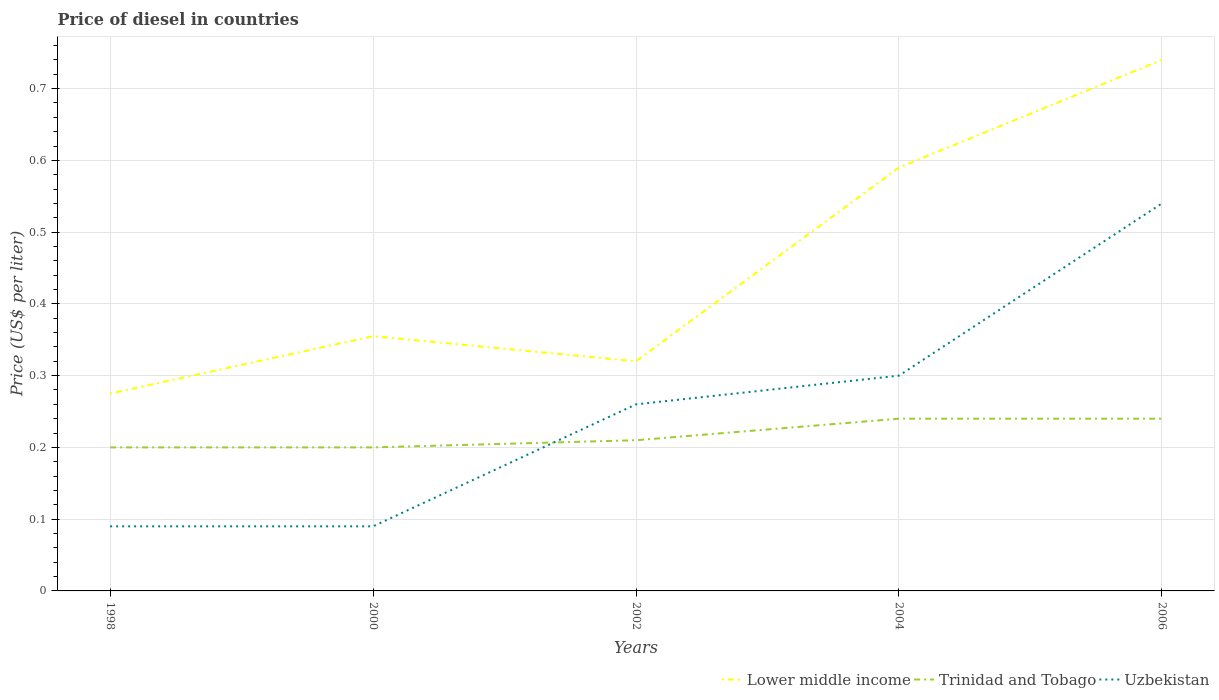Does the line corresponding to Lower middle income intersect with the line corresponding to Uzbekistan?
Keep it short and to the point. No. Is the number of lines equal to the number of legend labels?
Give a very brief answer. Yes. Across all years, what is the maximum price of diesel in Trinidad and Tobago?
Offer a terse response. 0.2. What is the total price of diesel in Uzbekistan in the graph?
Ensure brevity in your answer.  0. What is the difference between the highest and the second highest price of diesel in Trinidad and Tobago?
Ensure brevity in your answer.  0.04. Is the price of diesel in Uzbekistan strictly greater than the price of diesel in Trinidad and Tobago over the years?
Your response must be concise. No. What is the difference between two consecutive major ticks on the Y-axis?
Provide a short and direct response. 0.1. Are the values on the major ticks of Y-axis written in scientific E-notation?
Ensure brevity in your answer.  No. Does the graph contain grids?
Offer a terse response. Yes. How are the legend labels stacked?
Provide a short and direct response. Horizontal. What is the title of the graph?
Offer a very short reply. Price of diesel in countries. What is the label or title of the X-axis?
Make the answer very short. Years. What is the label or title of the Y-axis?
Provide a succinct answer. Price (US$ per liter). What is the Price (US$ per liter) of Lower middle income in 1998?
Offer a terse response. 0.28. What is the Price (US$ per liter) in Trinidad and Tobago in 1998?
Offer a very short reply. 0.2. What is the Price (US$ per liter) of Uzbekistan in 1998?
Provide a short and direct response. 0.09. What is the Price (US$ per liter) of Lower middle income in 2000?
Your answer should be very brief. 0.35. What is the Price (US$ per liter) in Uzbekistan in 2000?
Provide a succinct answer. 0.09. What is the Price (US$ per liter) of Lower middle income in 2002?
Your response must be concise. 0.32. What is the Price (US$ per liter) in Trinidad and Tobago in 2002?
Keep it short and to the point. 0.21. What is the Price (US$ per liter) of Uzbekistan in 2002?
Ensure brevity in your answer.  0.26. What is the Price (US$ per liter) of Lower middle income in 2004?
Your answer should be compact. 0.59. What is the Price (US$ per liter) of Trinidad and Tobago in 2004?
Provide a succinct answer. 0.24. What is the Price (US$ per liter) in Lower middle income in 2006?
Give a very brief answer. 0.74. What is the Price (US$ per liter) of Trinidad and Tobago in 2006?
Keep it short and to the point. 0.24. What is the Price (US$ per liter) in Uzbekistan in 2006?
Ensure brevity in your answer.  0.54. Across all years, what is the maximum Price (US$ per liter) in Lower middle income?
Offer a very short reply. 0.74. Across all years, what is the maximum Price (US$ per liter) of Trinidad and Tobago?
Provide a succinct answer. 0.24. Across all years, what is the maximum Price (US$ per liter) of Uzbekistan?
Give a very brief answer. 0.54. Across all years, what is the minimum Price (US$ per liter) of Lower middle income?
Provide a short and direct response. 0.28. Across all years, what is the minimum Price (US$ per liter) of Trinidad and Tobago?
Give a very brief answer. 0.2. Across all years, what is the minimum Price (US$ per liter) of Uzbekistan?
Keep it short and to the point. 0.09. What is the total Price (US$ per liter) of Lower middle income in the graph?
Provide a short and direct response. 2.28. What is the total Price (US$ per liter) of Trinidad and Tobago in the graph?
Your answer should be very brief. 1.09. What is the total Price (US$ per liter) in Uzbekistan in the graph?
Provide a short and direct response. 1.28. What is the difference between the Price (US$ per liter) of Lower middle income in 1998 and that in 2000?
Your answer should be compact. -0.08. What is the difference between the Price (US$ per liter) in Lower middle income in 1998 and that in 2002?
Provide a succinct answer. -0.04. What is the difference between the Price (US$ per liter) of Trinidad and Tobago in 1998 and that in 2002?
Your answer should be very brief. -0.01. What is the difference between the Price (US$ per liter) of Uzbekistan in 1998 and that in 2002?
Make the answer very short. -0.17. What is the difference between the Price (US$ per liter) of Lower middle income in 1998 and that in 2004?
Your response must be concise. -0.32. What is the difference between the Price (US$ per liter) in Trinidad and Tobago in 1998 and that in 2004?
Offer a very short reply. -0.04. What is the difference between the Price (US$ per liter) of Uzbekistan in 1998 and that in 2004?
Provide a succinct answer. -0.21. What is the difference between the Price (US$ per liter) in Lower middle income in 1998 and that in 2006?
Ensure brevity in your answer.  -0.47. What is the difference between the Price (US$ per liter) of Trinidad and Tobago in 1998 and that in 2006?
Keep it short and to the point. -0.04. What is the difference between the Price (US$ per liter) of Uzbekistan in 1998 and that in 2006?
Keep it short and to the point. -0.45. What is the difference between the Price (US$ per liter) of Lower middle income in 2000 and that in 2002?
Offer a very short reply. 0.04. What is the difference between the Price (US$ per liter) in Trinidad and Tobago in 2000 and that in 2002?
Provide a succinct answer. -0.01. What is the difference between the Price (US$ per liter) in Uzbekistan in 2000 and that in 2002?
Make the answer very short. -0.17. What is the difference between the Price (US$ per liter) of Lower middle income in 2000 and that in 2004?
Give a very brief answer. -0.23. What is the difference between the Price (US$ per liter) in Trinidad and Tobago in 2000 and that in 2004?
Offer a very short reply. -0.04. What is the difference between the Price (US$ per liter) in Uzbekistan in 2000 and that in 2004?
Give a very brief answer. -0.21. What is the difference between the Price (US$ per liter) in Lower middle income in 2000 and that in 2006?
Provide a succinct answer. -0.39. What is the difference between the Price (US$ per liter) of Trinidad and Tobago in 2000 and that in 2006?
Make the answer very short. -0.04. What is the difference between the Price (US$ per liter) of Uzbekistan in 2000 and that in 2006?
Ensure brevity in your answer.  -0.45. What is the difference between the Price (US$ per liter) in Lower middle income in 2002 and that in 2004?
Ensure brevity in your answer.  -0.27. What is the difference between the Price (US$ per liter) in Trinidad and Tobago in 2002 and that in 2004?
Your answer should be very brief. -0.03. What is the difference between the Price (US$ per liter) in Uzbekistan in 2002 and that in 2004?
Provide a short and direct response. -0.04. What is the difference between the Price (US$ per liter) of Lower middle income in 2002 and that in 2006?
Your answer should be very brief. -0.42. What is the difference between the Price (US$ per liter) of Trinidad and Tobago in 2002 and that in 2006?
Your response must be concise. -0.03. What is the difference between the Price (US$ per liter) of Uzbekistan in 2002 and that in 2006?
Your response must be concise. -0.28. What is the difference between the Price (US$ per liter) of Lower middle income in 2004 and that in 2006?
Make the answer very short. -0.15. What is the difference between the Price (US$ per liter) in Uzbekistan in 2004 and that in 2006?
Provide a succinct answer. -0.24. What is the difference between the Price (US$ per liter) of Lower middle income in 1998 and the Price (US$ per liter) of Trinidad and Tobago in 2000?
Provide a short and direct response. 0.07. What is the difference between the Price (US$ per liter) in Lower middle income in 1998 and the Price (US$ per liter) in Uzbekistan in 2000?
Provide a succinct answer. 0.18. What is the difference between the Price (US$ per liter) in Trinidad and Tobago in 1998 and the Price (US$ per liter) in Uzbekistan in 2000?
Keep it short and to the point. 0.11. What is the difference between the Price (US$ per liter) of Lower middle income in 1998 and the Price (US$ per liter) of Trinidad and Tobago in 2002?
Give a very brief answer. 0.07. What is the difference between the Price (US$ per liter) in Lower middle income in 1998 and the Price (US$ per liter) in Uzbekistan in 2002?
Offer a terse response. 0.01. What is the difference between the Price (US$ per liter) of Trinidad and Tobago in 1998 and the Price (US$ per liter) of Uzbekistan in 2002?
Keep it short and to the point. -0.06. What is the difference between the Price (US$ per liter) of Lower middle income in 1998 and the Price (US$ per liter) of Trinidad and Tobago in 2004?
Your response must be concise. 0.04. What is the difference between the Price (US$ per liter) in Lower middle income in 1998 and the Price (US$ per liter) in Uzbekistan in 2004?
Give a very brief answer. -0.03. What is the difference between the Price (US$ per liter) of Trinidad and Tobago in 1998 and the Price (US$ per liter) of Uzbekistan in 2004?
Give a very brief answer. -0.1. What is the difference between the Price (US$ per liter) in Lower middle income in 1998 and the Price (US$ per liter) in Trinidad and Tobago in 2006?
Your answer should be compact. 0.04. What is the difference between the Price (US$ per liter) in Lower middle income in 1998 and the Price (US$ per liter) in Uzbekistan in 2006?
Offer a very short reply. -0.27. What is the difference between the Price (US$ per liter) in Trinidad and Tobago in 1998 and the Price (US$ per liter) in Uzbekistan in 2006?
Provide a short and direct response. -0.34. What is the difference between the Price (US$ per liter) in Lower middle income in 2000 and the Price (US$ per liter) in Trinidad and Tobago in 2002?
Keep it short and to the point. 0.14. What is the difference between the Price (US$ per liter) of Lower middle income in 2000 and the Price (US$ per liter) of Uzbekistan in 2002?
Offer a very short reply. 0.1. What is the difference between the Price (US$ per liter) in Trinidad and Tobago in 2000 and the Price (US$ per liter) in Uzbekistan in 2002?
Your answer should be very brief. -0.06. What is the difference between the Price (US$ per liter) in Lower middle income in 2000 and the Price (US$ per liter) in Trinidad and Tobago in 2004?
Your answer should be very brief. 0.12. What is the difference between the Price (US$ per liter) of Lower middle income in 2000 and the Price (US$ per liter) of Uzbekistan in 2004?
Your answer should be compact. 0.06. What is the difference between the Price (US$ per liter) in Trinidad and Tobago in 2000 and the Price (US$ per liter) in Uzbekistan in 2004?
Offer a very short reply. -0.1. What is the difference between the Price (US$ per liter) in Lower middle income in 2000 and the Price (US$ per liter) in Trinidad and Tobago in 2006?
Give a very brief answer. 0.12. What is the difference between the Price (US$ per liter) in Lower middle income in 2000 and the Price (US$ per liter) in Uzbekistan in 2006?
Provide a short and direct response. -0.18. What is the difference between the Price (US$ per liter) in Trinidad and Tobago in 2000 and the Price (US$ per liter) in Uzbekistan in 2006?
Your answer should be very brief. -0.34. What is the difference between the Price (US$ per liter) in Lower middle income in 2002 and the Price (US$ per liter) in Trinidad and Tobago in 2004?
Your response must be concise. 0.08. What is the difference between the Price (US$ per liter) of Trinidad and Tobago in 2002 and the Price (US$ per liter) of Uzbekistan in 2004?
Provide a short and direct response. -0.09. What is the difference between the Price (US$ per liter) in Lower middle income in 2002 and the Price (US$ per liter) in Trinidad and Tobago in 2006?
Ensure brevity in your answer.  0.08. What is the difference between the Price (US$ per liter) of Lower middle income in 2002 and the Price (US$ per liter) of Uzbekistan in 2006?
Give a very brief answer. -0.22. What is the difference between the Price (US$ per liter) in Trinidad and Tobago in 2002 and the Price (US$ per liter) in Uzbekistan in 2006?
Make the answer very short. -0.33. What is the difference between the Price (US$ per liter) of Lower middle income in 2004 and the Price (US$ per liter) of Trinidad and Tobago in 2006?
Provide a short and direct response. 0.35. What is the difference between the Price (US$ per liter) in Trinidad and Tobago in 2004 and the Price (US$ per liter) in Uzbekistan in 2006?
Make the answer very short. -0.3. What is the average Price (US$ per liter) in Lower middle income per year?
Keep it short and to the point. 0.46. What is the average Price (US$ per liter) in Trinidad and Tobago per year?
Provide a succinct answer. 0.22. What is the average Price (US$ per liter) of Uzbekistan per year?
Your answer should be very brief. 0.26. In the year 1998, what is the difference between the Price (US$ per liter) in Lower middle income and Price (US$ per liter) in Trinidad and Tobago?
Give a very brief answer. 0.07. In the year 1998, what is the difference between the Price (US$ per liter) in Lower middle income and Price (US$ per liter) in Uzbekistan?
Your response must be concise. 0.18. In the year 1998, what is the difference between the Price (US$ per liter) of Trinidad and Tobago and Price (US$ per liter) of Uzbekistan?
Give a very brief answer. 0.11. In the year 2000, what is the difference between the Price (US$ per liter) in Lower middle income and Price (US$ per liter) in Trinidad and Tobago?
Your response must be concise. 0.15. In the year 2000, what is the difference between the Price (US$ per liter) in Lower middle income and Price (US$ per liter) in Uzbekistan?
Provide a short and direct response. 0.27. In the year 2000, what is the difference between the Price (US$ per liter) of Trinidad and Tobago and Price (US$ per liter) of Uzbekistan?
Your answer should be compact. 0.11. In the year 2002, what is the difference between the Price (US$ per liter) of Lower middle income and Price (US$ per liter) of Trinidad and Tobago?
Your response must be concise. 0.11. In the year 2002, what is the difference between the Price (US$ per liter) in Lower middle income and Price (US$ per liter) in Uzbekistan?
Offer a terse response. 0.06. In the year 2002, what is the difference between the Price (US$ per liter) in Trinidad and Tobago and Price (US$ per liter) in Uzbekistan?
Your answer should be very brief. -0.05. In the year 2004, what is the difference between the Price (US$ per liter) of Lower middle income and Price (US$ per liter) of Uzbekistan?
Offer a very short reply. 0.29. In the year 2004, what is the difference between the Price (US$ per liter) in Trinidad and Tobago and Price (US$ per liter) in Uzbekistan?
Keep it short and to the point. -0.06. In the year 2006, what is the difference between the Price (US$ per liter) of Lower middle income and Price (US$ per liter) of Trinidad and Tobago?
Make the answer very short. 0.5. In the year 2006, what is the difference between the Price (US$ per liter) in Lower middle income and Price (US$ per liter) in Uzbekistan?
Provide a short and direct response. 0.2. What is the ratio of the Price (US$ per liter) in Lower middle income in 1998 to that in 2000?
Provide a succinct answer. 0.77. What is the ratio of the Price (US$ per liter) of Lower middle income in 1998 to that in 2002?
Make the answer very short. 0.86. What is the ratio of the Price (US$ per liter) in Uzbekistan in 1998 to that in 2002?
Offer a terse response. 0.35. What is the ratio of the Price (US$ per liter) in Lower middle income in 1998 to that in 2004?
Make the answer very short. 0.47. What is the ratio of the Price (US$ per liter) of Lower middle income in 1998 to that in 2006?
Offer a very short reply. 0.37. What is the ratio of the Price (US$ per liter) of Trinidad and Tobago in 1998 to that in 2006?
Make the answer very short. 0.83. What is the ratio of the Price (US$ per liter) in Lower middle income in 2000 to that in 2002?
Your answer should be very brief. 1.11. What is the ratio of the Price (US$ per liter) in Trinidad and Tobago in 2000 to that in 2002?
Provide a short and direct response. 0.95. What is the ratio of the Price (US$ per liter) in Uzbekistan in 2000 to that in 2002?
Provide a succinct answer. 0.35. What is the ratio of the Price (US$ per liter) in Lower middle income in 2000 to that in 2004?
Your answer should be compact. 0.6. What is the ratio of the Price (US$ per liter) of Trinidad and Tobago in 2000 to that in 2004?
Your answer should be very brief. 0.83. What is the ratio of the Price (US$ per liter) of Uzbekistan in 2000 to that in 2004?
Give a very brief answer. 0.3. What is the ratio of the Price (US$ per liter) in Lower middle income in 2000 to that in 2006?
Make the answer very short. 0.48. What is the ratio of the Price (US$ per liter) of Trinidad and Tobago in 2000 to that in 2006?
Keep it short and to the point. 0.83. What is the ratio of the Price (US$ per liter) of Lower middle income in 2002 to that in 2004?
Provide a succinct answer. 0.54. What is the ratio of the Price (US$ per liter) in Trinidad and Tobago in 2002 to that in 2004?
Give a very brief answer. 0.88. What is the ratio of the Price (US$ per liter) of Uzbekistan in 2002 to that in 2004?
Keep it short and to the point. 0.87. What is the ratio of the Price (US$ per liter) in Lower middle income in 2002 to that in 2006?
Make the answer very short. 0.43. What is the ratio of the Price (US$ per liter) of Uzbekistan in 2002 to that in 2006?
Provide a succinct answer. 0.48. What is the ratio of the Price (US$ per liter) in Lower middle income in 2004 to that in 2006?
Keep it short and to the point. 0.8. What is the ratio of the Price (US$ per liter) in Uzbekistan in 2004 to that in 2006?
Keep it short and to the point. 0.56. What is the difference between the highest and the second highest Price (US$ per liter) in Uzbekistan?
Offer a very short reply. 0.24. What is the difference between the highest and the lowest Price (US$ per liter) of Lower middle income?
Your response must be concise. 0.47. What is the difference between the highest and the lowest Price (US$ per liter) in Trinidad and Tobago?
Ensure brevity in your answer.  0.04. What is the difference between the highest and the lowest Price (US$ per liter) in Uzbekistan?
Give a very brief answer. 0.45. 